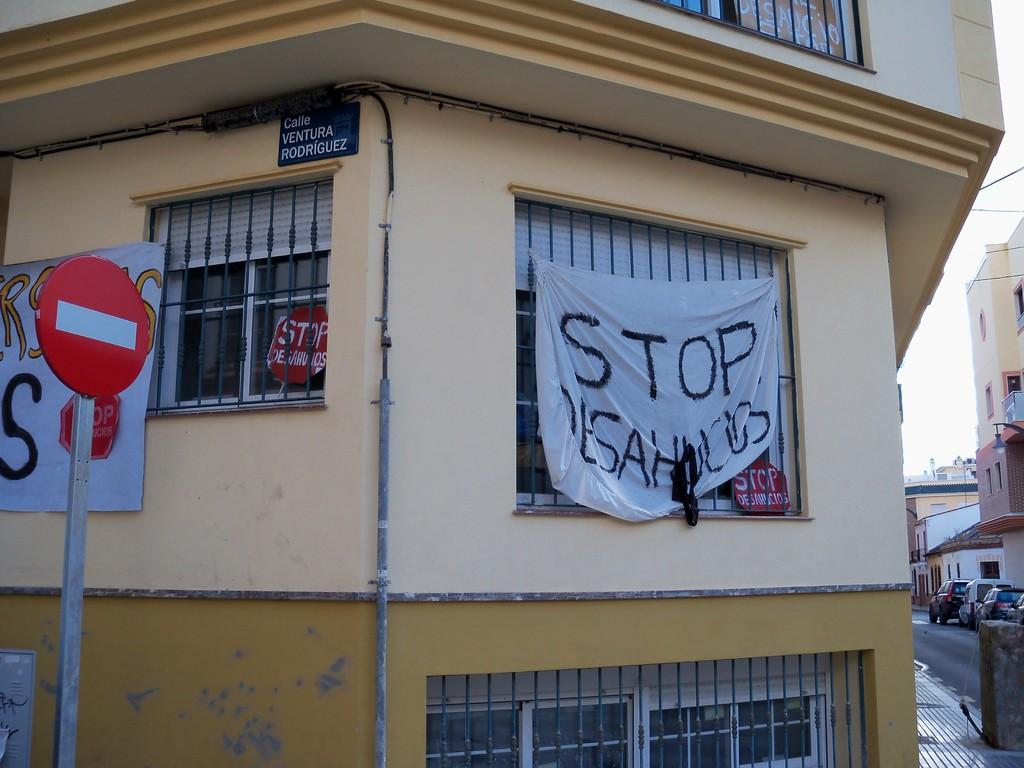What is one of the main elements visible in the image? The sky is visible in the image. What can be seen in the sky? Clouds are present in the image. What type of structures are visible in the image? There are buildings in the image. What part of the buildings can be seen? Windows are visible in the image. Are there any signs or advertisements in the image? Yes, sign boards are present in the image. Are there any special decorations or announcements in the image? Yes, banners are present in the image. What is happening on the ground in the image? There are vehicles on the road in the image. What type of pest can be seen crawling on the banners in the image? There are no pests visible in the image, as it primarily features buildings, vehicles, and signage. 